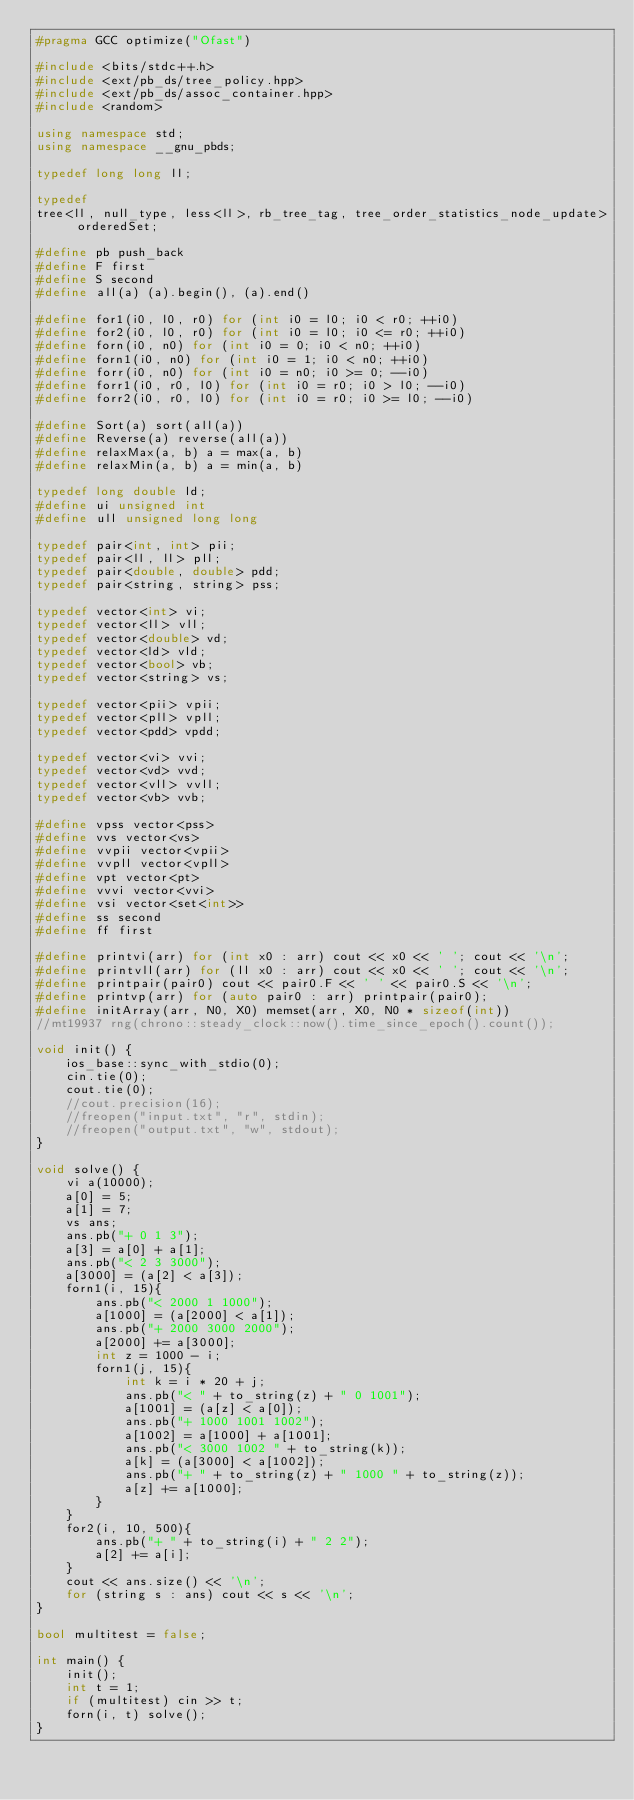<code> <loc_0><loc_0><loc_500><loc_500><_C++_>#pragma GCC optimize("Ofast")

#include <bits/stdc++.h>
#include <ext/pb_ds/tree_policy.hpp>
#include <ext/pb_ds/assoc_container.hpp>
#include <random>

using namespace std;
using namespace __gnu_pbds;

typedef long long ll;

typedef
tree<ll, null_type, less<ll>, rb_tree_tag, tree_order_statistics_node_update> orderedSet;

#define pb push_back
#define F first
#define S second
#define all(a) (a).begin(), (a).end()

#define for1(i0, l0, r0) for (int i0 = l0; i0 < r0; ++i0)
#define for2(i0, l0, r0) for (int i0 = l0; i0 <= r0; ++i0)
#define forn(i0, n0) for (int i0 = 0; i0 < n0; ++i0)
#define forn1(i0, n0) for (int i0 = 1; i0 < n0; ++i0)
#define forr(i0, n0) for (int i0 = n0; i0 >= 0; --i0)
#define forr1(i0, r0, l0) for (int i0 = r0; i0 > l0; --i0)
#define forr2(i0, r0, l0) for (int i0 = r0; i0 >= l0; --i0)

#define Sort(a) sort(all(a))
#define Reverse(a) reverse(all(a))
#define relaxMax(a, b) a = max(a, b)
#define relaxMin(a, b) a = min(a, b)

typedef long double ld;
#define ui unsigned int
#define ull unsigned long long

typedef pair<int, int> pii;
typedef pair<ll, ll> pll;
typedef pair<double, double> pdd;
typedef pair<string, string> pss;

typedef vector<int> vi;
typedef vector<ll> vll;
typedef vector<double> vd;
typedef vector<ld> vld;
typedef vector<bool> vb;
typedef vector<string> vs;

typedef vector<pii> vpii;
typedef vector<pll> vpll;
typedef vector<pdd> vpdd;

typedef vector<vi> vvi;
typedef vector<vd> vvd;
typedef vector<vll> vvll;
typedef vector<vb> vvb;

#define vpss vector<pss>
#define vvs vector<vs>
#define vvpii vector<vpii>
#define vvpll vector<vpll>
#define vpt vector<pt>
#define vvvi vector<vvi>
#define vsi vector<set<int>>
#define ss second
#define ff first

#define printvi(arr) for (int x0 : arr) cout << x0 << ' '; cout << '\n';
#define printvll(arr) for (ll x0 : arr) cout << x0 << ' '; cout << '\n';
#define printpair(pair0) cout << pair0.F << ' ' << pair0.S << '\n';
#define printvp(arr) for (auto pair0 : arr) printpair(pair0);
#define initArray(arr, N0, X0) memset(arr, X0, N0 * sizeof(int))
//mt19937 rng(chrono::steady_clock::now().time_since_epoch().count());

void init() {
    ios_base::sync_with_stdio(0);
    cin.tie(0);
    cout.tie(0);
    //cout.precision(16);
    //freopen("input.txt", "r", stdin);
    //freopen("output.txt", "w", stdout);
}

void solve() {
    vi a(10000);
    a[0] = 5;
    a[1] = 7;
    vs ans;
    ans.pb("+ 0 1 3");
    a[3] = a[0] + a[1];
    ans.pb("< 2 3 3000");
    a[3000] = (a[2] < a[3]);
    forn1(i, 15){
        ans.pb("< 2000 1 1000");
        a[1000] = (a[2000] < a[1]);
        ans.pb("+ 2000 3000 2000");
        a[2000] += a[3000];
        int z = 1000 - i;
        forn1(j, 15){
            int k = i * 20 + j;
            ans.pb("< " + to_string(z) + " 0 1001");
            a[1001] = (a[z] < a[0]);
            ans.pb("+ 1000 1001 1002");
            a[1002] = a[1000] + a[1001];
            ans.pb("< 3000 1002 " + to_string(k));
            a[k] = (a[3000] < a[1002]);
            ans.pb("+ " + to_string(z) + " 1000 " + to_string(z));
            a[z] += a[1000];
        }
    }
    for2(i, 10, 500){
        ans.pb("+ " + to_string(i) + " 2 2");
        a[2] += a[i];
    }
    cout << ans.size() << '\n';
    for (string s : ans) cout << s << '\n';
}

bool multitest = false;

int main() {
    init();
    int t = 1;
    if (multitest) cin >> t;
    forn(i, t) solve();
}</code> 